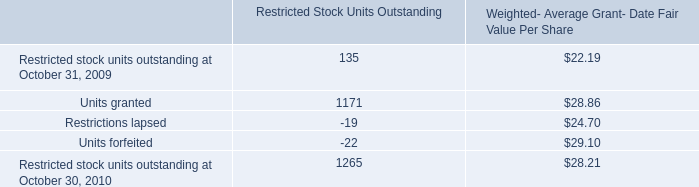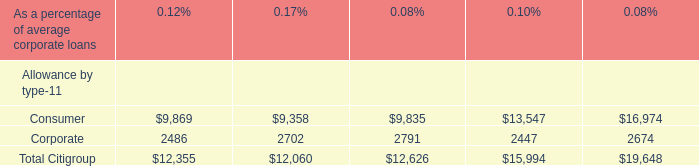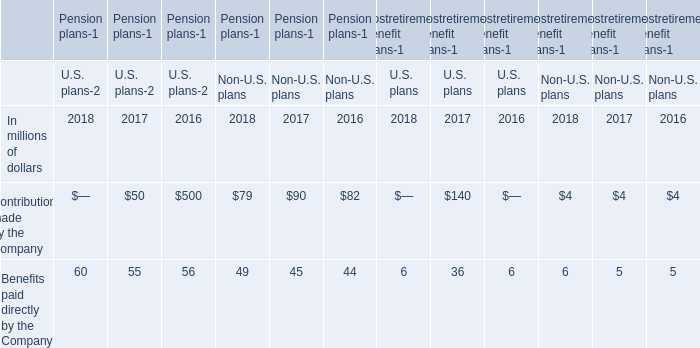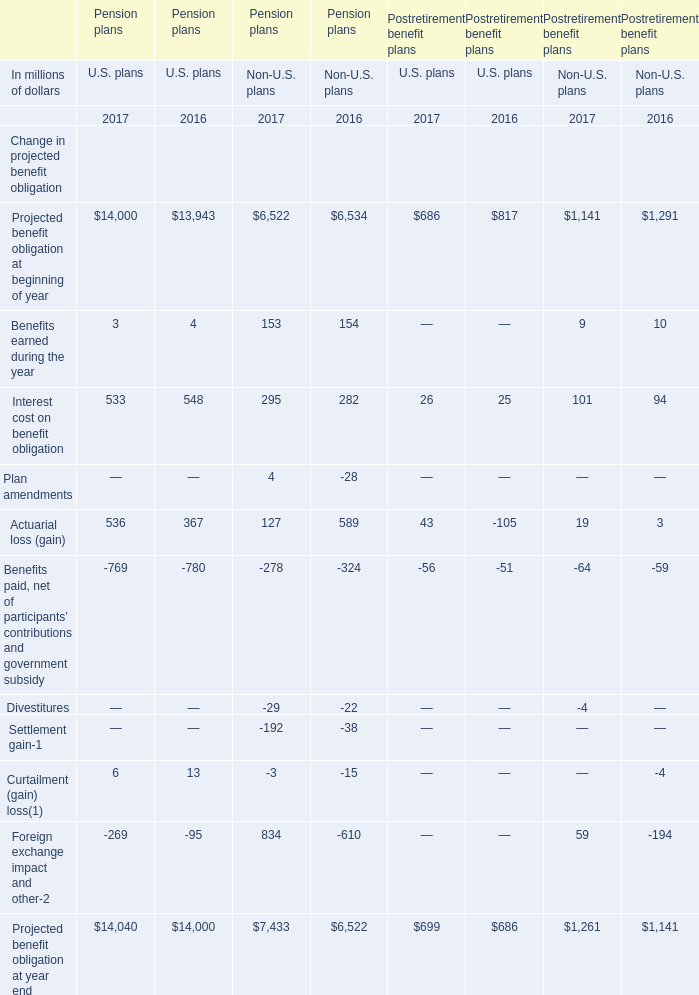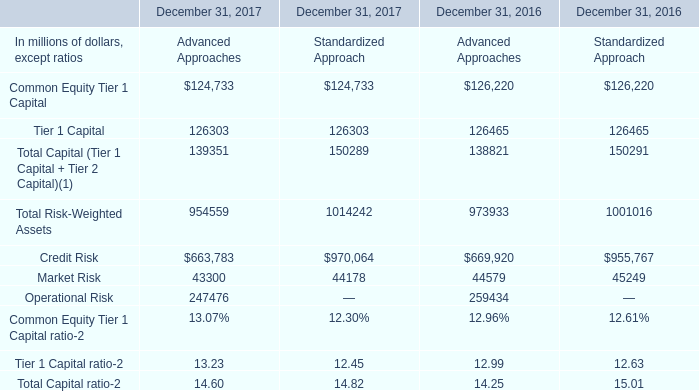What's the difference of Projected benefit obligation at beginning of year of U.S. Pension plans between 2017 and 2016? (in million) 
Computations: (14000 - 13943)
Answer: 57.0. 